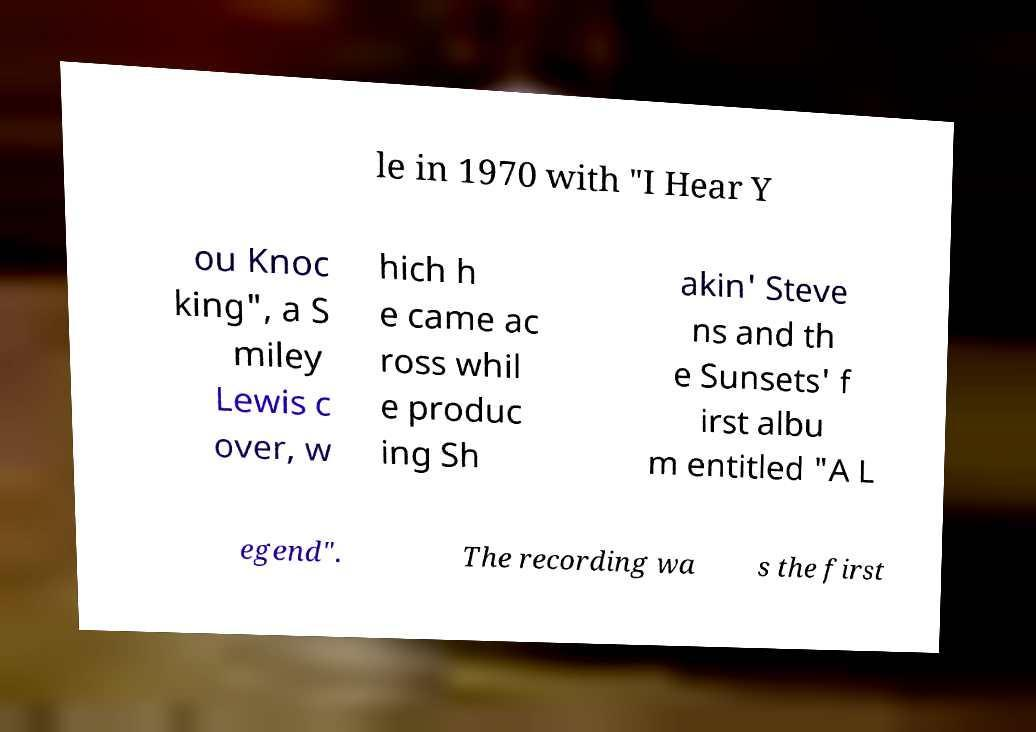Please identify and transcribe the text found in this image. le in 1970 with "I Hear Y ou Knoc king", a S miley Lewis c over, w hich h e came ac ross whil e produc ing Sh akin' Steve ns and th e Sunsets' f irst albu m entitled "A L egend". The recording wa s the first 